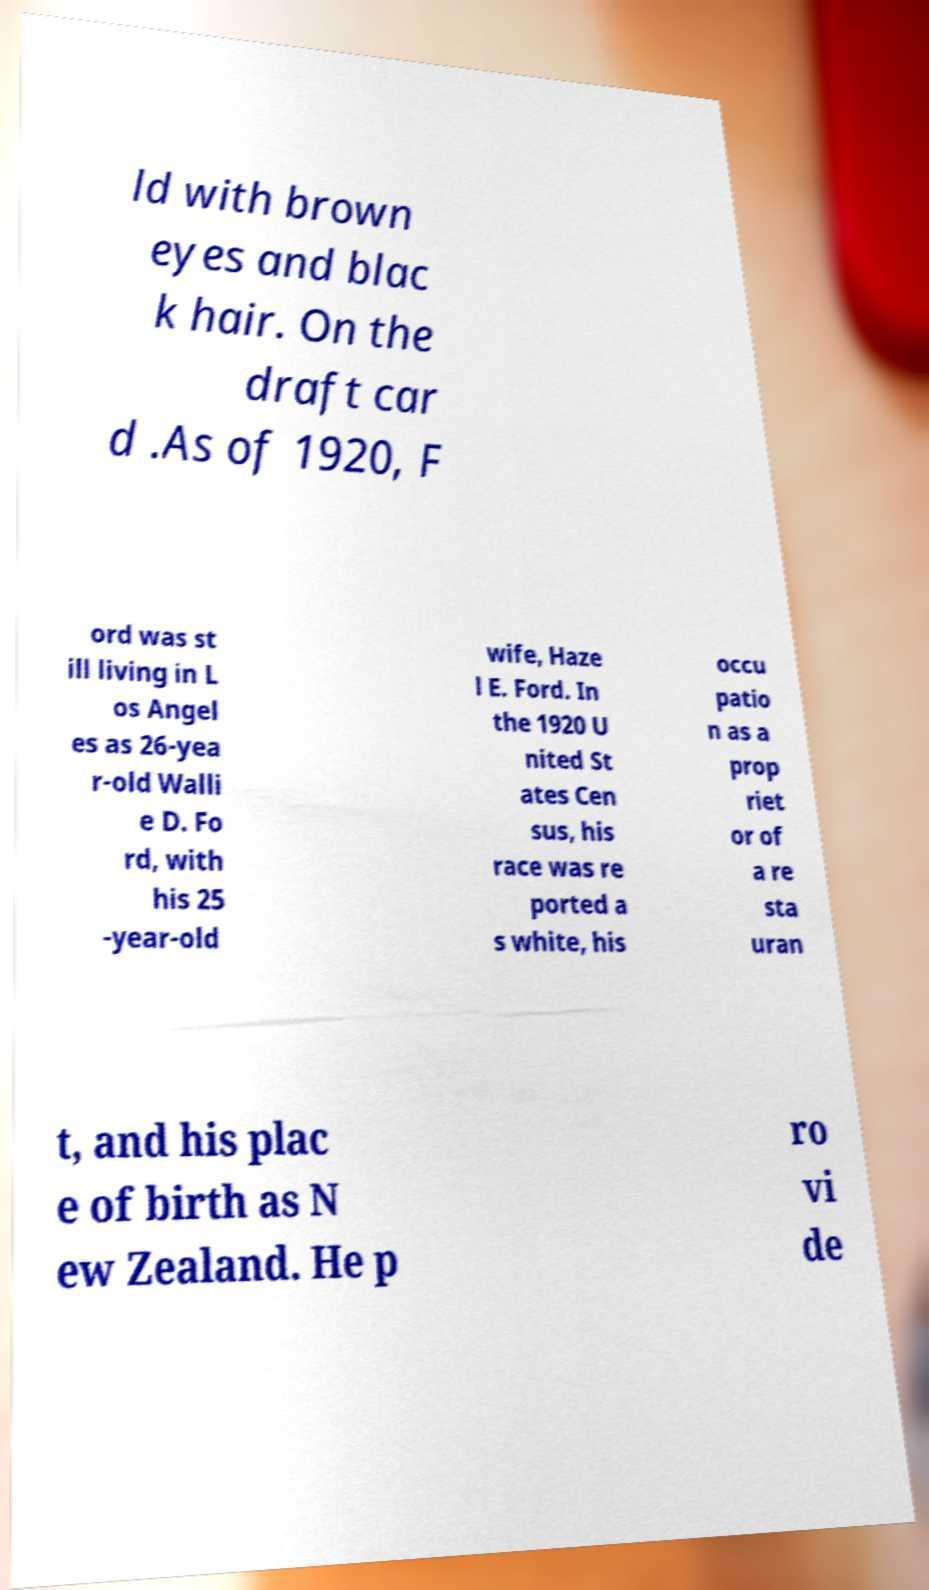What messages or text are displayed in this image? I need them in a readable, typed format. ld with brown eyes and blac k hair. On the draft car d .As of 1920, F ord was st ill living in L os Angel es as 26-yea r-old Walli e D. Fo rd, with his 25 -year-old wife, Haze l E. Ford. In the 1920 U nited St ates Cen sus, his race was re ported a s white, his occu patio n as a prop riet or of a re sta uran t, and his plac e of birth as N ew Zealand. He p ro vi de 